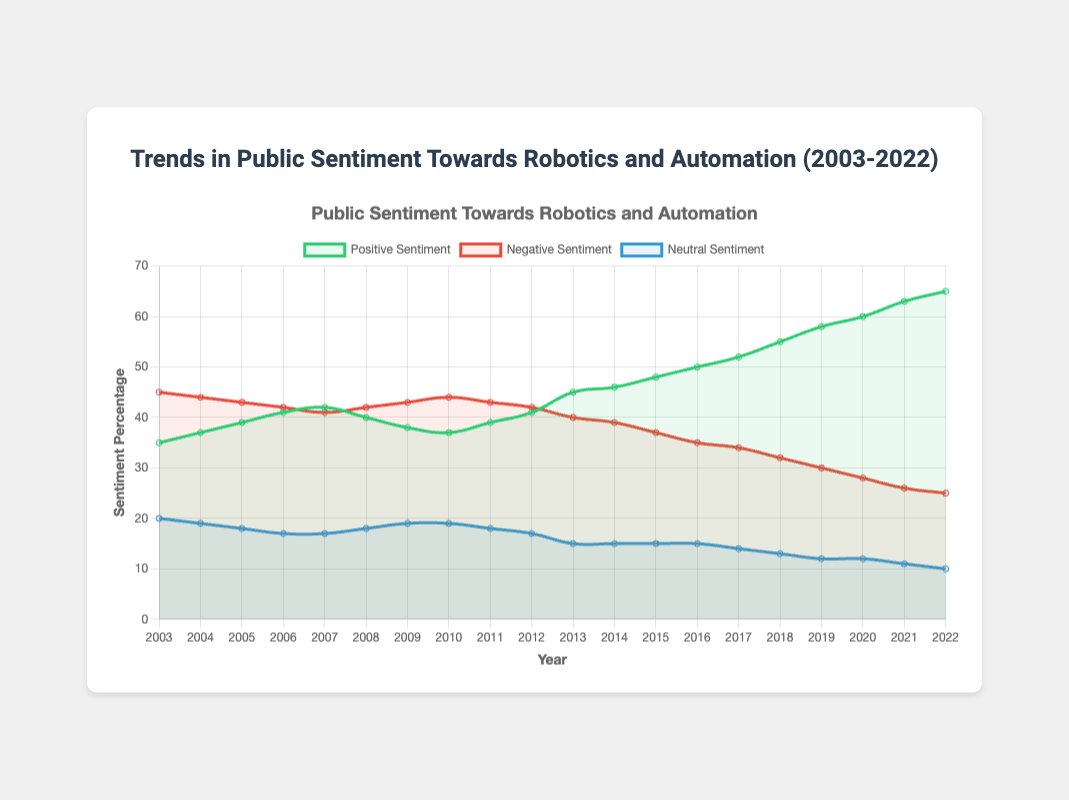What is the trend in positive sentiment over the 20 years? The positive sentiment shows an increasing trend over the years. Starting at 35% in 2003, it gradually rises each year, reaching 65% in 2022.
Answer: Increasing Which year had the highest negative sentiment? By analyzing the negative sentiment data, the highest point is in 2003 with 45%.
Answer: 2003 What is the difference in neutral sentiment between 2003 and 2022? The neutral sentiment in 2003 was 20% and reduced to 10% in 2022. The difference is 20% - 10% = 10%.
Answer: 10% How does the negative sentiment in 2020 compare to that in 2010? In 2010, the negative sentiment was 44%, while in 2020, it was 28%. 2020 has a lower negative sentiment compared to 2010.
Answer: Lower in 2020 What was the average positive sentiment from 2003 to 2022? Summing the positive sentiment values between 2003 and 2022: (35 + 37 + 39 + 41 + 42 + 40 + 38 + 37 + 39 + 41 + 45 + 46 + 48 + 50 + 52 + 55 + 58 + 60 + 63 + 65) = 872. There are 20 years, so the average is 872 / 20 = 43.6%.
Answer: 43.6% By how much did positive sentiment increase from 2003 to 2022? The positive sentiment was 35% in 2003 and 65% in 2022. The increase is 65% - 35% = 30%.
Answer: 30% Which sentiment category has decreased the most over the years? Comparing percentage changes from 2003 to 2022: Negative sentiment dropped from 45% to 25% (a 20% decrease), whereas Neutral sentiment decreased from 20% to 10% (a 10% decrease), and Positive sentiment increased. The negative sentiment showed the greatest decrease.
Answer: Negative Sentiment In which year do positive and negative sentiments intersect or come closest in value? The closest intersection is around 2007, where positive sentiment is at 42% and negative sentiment is at 41%.
Answer: 2007 What is the overall trend for neutral sentiment from 2003 to 2022? The neutral sentiment shows a decreasing trend from 20% in 2003 down to 10% in 2022.
Answer: Decreasing Compare the average sentiment values in the first decade (2003-2012) with the second decade (2013-2022) for positive sentiment. First decade (2003-2012), summing positive sentiment: (35 + 37 + 39 + 41 + 42 + 40 + 38 + 37 + 39 + 41) = 389, average = 389 / 10 = 38.9%. Second decade (2013-2022), summing positive sentiment: (45 + 46 + 48 + 50 + 52 + 55 + 58 + 60 + 63 + 65) = 542, average = 542 / 10 = 54.2%. The average positive sentiment is higher in the second decade.
Answer: Higher in the second decade 